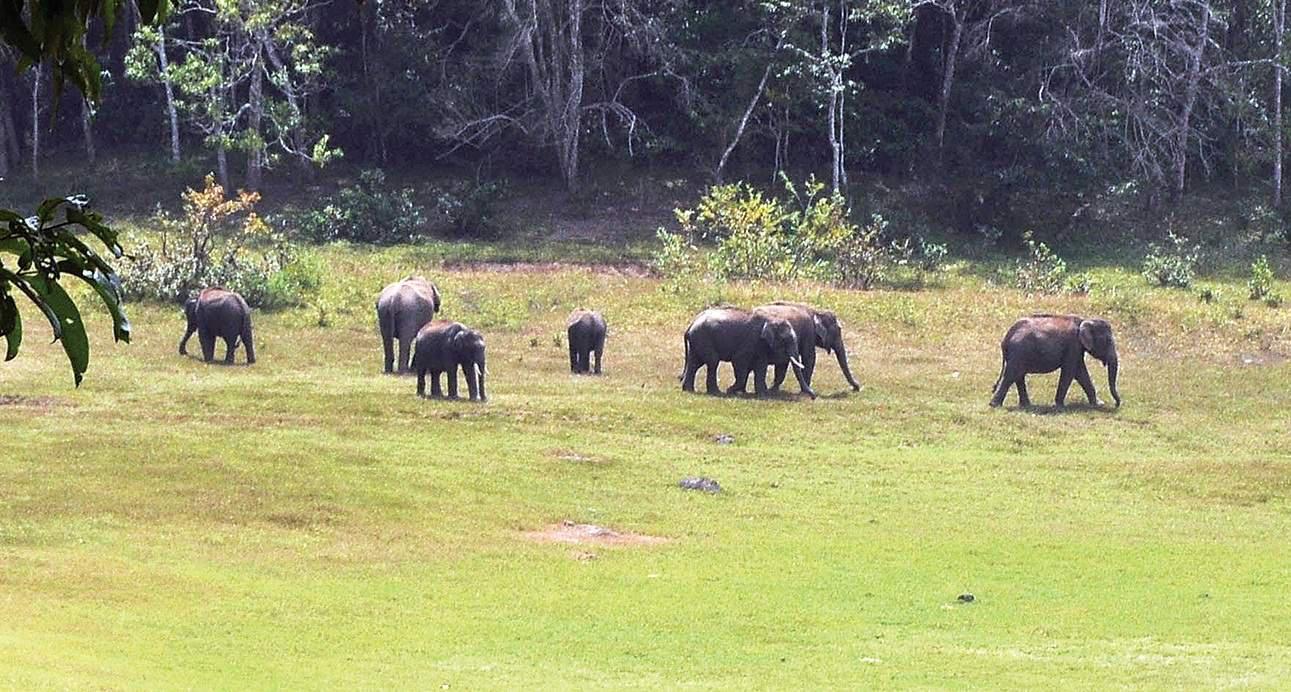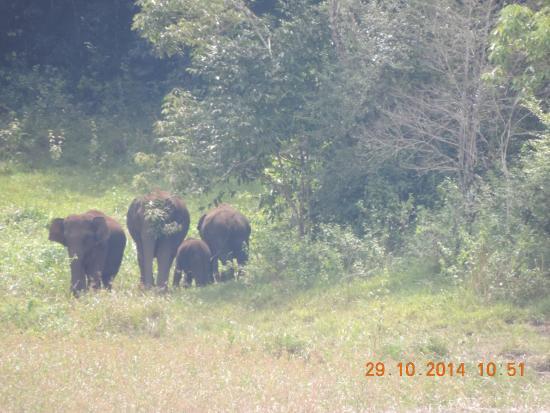The first image is the image on the left, the second image is the image on the right. Given the left and right images, does the statement "The animals in the image on the right are near watere." hold true? Answer yes or no. No. The first image is the image on the left, the second image is the image on the right. Evaluate the accuracy of this statement regarding the images: "An image shows a group of elephants near a pool of water, but not in the water.". Is it true? Answer yes or no. No. 